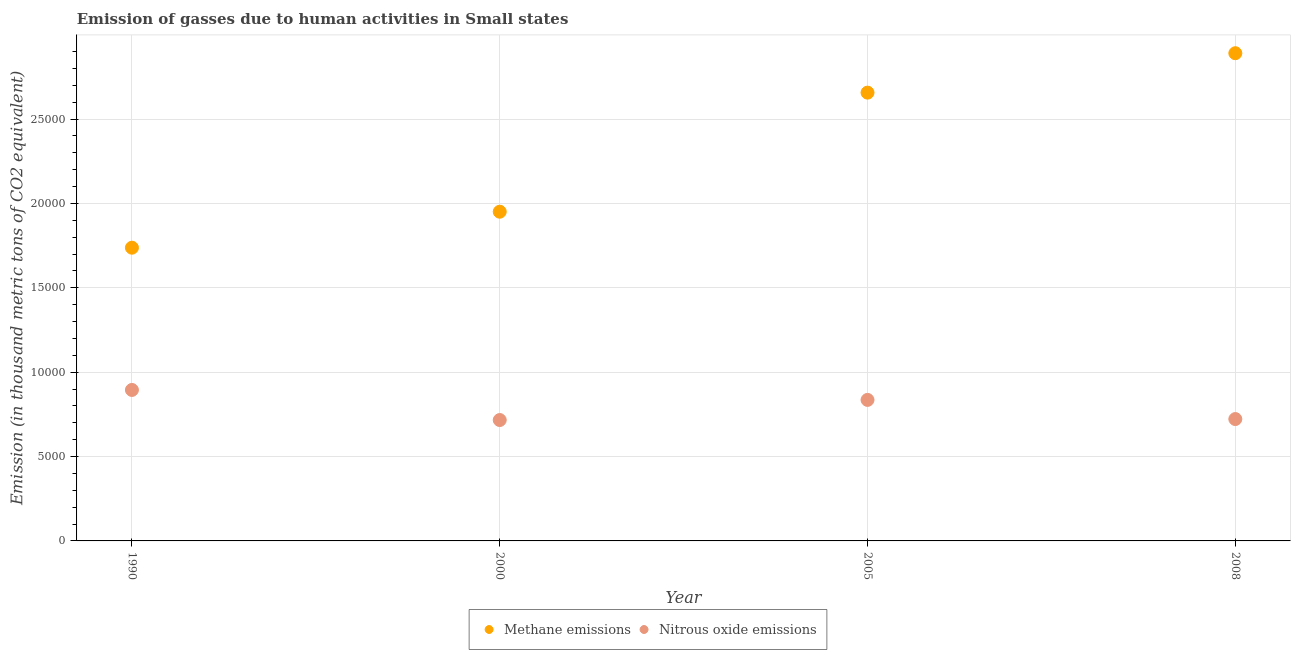How many different coloured dotlines are there?
Ensure brevity in your answer.  2. Is the number of dotlines equal to the number of legend labels?
Make the answer very short. Yes. What is the amount of methane emissions in 2008?
Keep it short and to the point. 2.89e+04. Across all years, what is the maximum amount of nitrous oxide emissions?
Offer a very short reply. 8947.8. Across all years, what is the minimum amount of methane emissions?
Ensure brevity in your answer.  1.74e+04. In which year was the amount of methane emissions maximum?
Offer a terse response. 2008. What is the total amount of methane emissions in the graph?
Offer a terse response. 9.24e+04. What is the difference between the amount of methane emissions in 1990 and that in 2000?
Your answer should be very brief. -2132.9. What is the difference between the amount of methane emissions in 2000 and the amount of nitrous oxide emissions in 2008?
Keep it short and to the point. 1.23e+04. What is the average amount of nitrous oxide emissions per year?
Offer a terse response. 7923.32. In the year 1990, what is the difference between the amount of methane emissions and amount of nitrous oxide emissions?
Ensure brevity in your answer.  8430.9. In how many years, is the amount of methane emissions greater than 9000 thousand metric tons?
Provide a short and direct response. 4. What is the ratio of the amount of nitrous oxide emissions in 2000 to that in 2005?
Offer a terse response. 0.86. What is the difference between the highest and the second highest amount of nitrous oxide emissions?
Give a very brief answer. 589.7. What is the difference between the highest and the lowest amount of methane emissions?
Make the answer very short. 1.15e+04. In how many years, is the amount of methane emissions greater than the average amount of methane emissions taken over all years?
Your response must be concise. 2. Is the sum of the amount of methane emissions in 1990 and 2005 greater than the maximum amount of nitrous oxide emissions across all years?
Provide a short and direct response. Yes. Does the amount of nitrous oxide emissions monotonically increase over the years?
Give a very brief answer. No. Is the amount of nitrous oxide emissions strictly greater than the amount of methane emissions over the years?
Ensure brevity in your answer.  No. How many dotlines are there?
Offer a very short reply. 2. What is the difference between two consecutive major ticks on the Y-axis?
Your answer should be compact. 5000. Are the values on the major ticks of Y-axis written in scientific E-notation?
Keep it short and to the point. No. Does the graph contain any zero values?
Offer a terse response. No. Where does the legend appear in the graph?
Provide a succinct answer. Bottom center. What is the title of the graph?
Give a very brief answer. Emission of gasses due to human activities in Small states. Does "National Tourists" appear as one of the legend labels in the graph?
Your response must be concise. No. What is the label or title of the X-axis?
Your answer should be compact. Year. What is the label or title of the Y-axis?
Provide a short and direct response. Emission (in thousand metric tons of CO2 equivalent). What is the Emission (in thousand metric tons of CO2 equivalent) in Methane emissions in 1990?
Your answer should be very brief. 1.74e+04. What is the Emission (in thousand metric tons of CO2 equivalent) of Nitrous oxide emissions in 1990?
Offer a very short reply. 8947.8. What is the Emission (in thousand metric tons of CO2 equivalent) of Methane emissions in 2000?
Ensure brevity in your answer.  1.95e+04. What is the Emission (in thousand metric tons of CO2 equivalent) in Nitrous oxide emissions in 2000?
Your answer should be compact. 7164.7. What is the Emission (in thousand metric tons of CO2 equivalent) of Methane emissions in 2005?
Offer a very short reply. 2.66e+04. What is the Emission (in thousand metric tons of CO2 equivalent) of Nitrous oxide emissions in 2005?
Offer a very short reply. 8358.1. What is the Emission (in thousand metric tons of CO2 equivalent) of Methane emissions in 2008?
Your answer should be very brief. 2.89e+04. What is the Emission (in thousand metric tons of CO2 equivalent) of Nitrous oxide emissions in 2008?
Give a very brief answer. 7222.7. Across all years, what is the maximum Emission (in thousand metric tons of CO2 equivalent) of Methane emissions?
Provide a succinct answer. 2.89e+04. Across all years, what is the maximum Emission (in thousand metric tons of CO2 equivalent) of Nitrous oxide emissions?
Provide a succinct answer. 8947.8. Across all years, what is the minimum Emission (in thousand metric tons of CO2 equivalent) in Methane emissions?
Offer a terse response. 1.74e+04. Across all years, what is the minimum Emission (in thousand metric tons of CO2 equivalent) of Nitrous oxide emissions?
Make the answer very short. 7164.7. What is the total Emission (in thousand metric tons of CO2 equivalent) of Methane emissions in the graph?
Offer a very short reply. 9.24e+04. What is the total Emission (in thousand metric tons of CO2 equivalent) of Nitrous oxide emissions in the graph?
Provide a succinct answer. 3.17e+04. What is the difference between the Emission (in thousand metric tons of CO2 equivalent) in Methane emissions in 1990 and that in 2000?
Your answer should be very brief. -2132.9. What is the difference between the Emission (in thousand metric tons of CO2 equivalent) of Nitrous oxide emissions in 1990 and that in 2000?
Your response must be concise. 1783.1. What is the difference between the Emission (in thousand metric tons of CO2 equivalent) of Methane emissions in 1990 and that in 2005?
Provide a short and direct response. -9189.8. What is the difference between the Emission (in thousand metric tons of CO2 equivalent) of Nitrous oxide emissions in 1990 and that in 2005?
Provide a short and direct response. 589.7. What is the difference between the Emission (in thousand metric tons of CO2 equivalent) in Methane emissions in 1990 and that in 2008?
Ensure brevity in your answer.  -1.15e+04. What is the difference between the Emission (in thousand metric tons of CO2 equivalent) of Nitrous oxide emissions in 1990 and that in 2008?
Keep it short and to the point. 1725.1. What is the difference between the Emission (in thousand metric tons of CO2 equivalent) in Methane emissions in 2000 and that in 2005?
Make the answer very short. -7056.9. What is the difference between the Emission (in thousand metric tons of CO2 equivalent) in Nitrous oxide emissions in 2000 and that in 2005?
Give a very brief answer. -1193.4. What is the difference between the Emission (in thousand metric tons of CO2 equivalent) in Methane emissions in 2000 and that in 2008?
Your answer should be very brief. -9393.1. What is the difference between the Emission (in thousand metric tons of CO2 equivalent) in Nitrous oxide emissions in 2000 and that in 2008?
Your response must be concise. -58. What is the difference between the Emission (in thousand metric tons of CO2 equivalent) of Methane emissions in 2005 and that in 2008?
Make the answer very short. -2336.2. What is the difference between the Emission (in thousand metric tons of CO2 equivalent) in Nitrous oxide emissions in 2005 and that in 2008?
Your response must be concise. 1135.4. What is the difference between the Emission (in thousand metric tons of CO2 equivalent) of Methane emissions in 1990 and the Emission (in thousand metric tons of CO2 equivalent) of Nitrous oxide emissions in 2000?
Make the answer very short. 1.02e+04. What is the difference between the Emission (in thousand metric tons of CO2 equivalent) in Methane emissions in 1990 and the Emission (in thousand metric tons of CO2 equivalent) in Nitrous oxide emissions in 2005?
Provide a short and direct response. 9020.6. What is the difference between the Emission (in thousand metric tons of CO2 equivalent) of Methane emissions in 1990 and the Emission (in thousand metric tons of CO2 equivalent) of Nitrous oxide emissions in 2008?
Your answer should be very brief. 1.02e+04. What is the difference between the Emission (in thousand metric tons of CO2 equivalent) in Methane emissions in 2000 and the Emission (in thousand metric tons of CO2 equivalent) in Nitrous oxide emissions in 2005?
Offer a very short reply. 1.12e+04. What is the difference between the Emission (in thousand metric tons of CO2 equivalent) in Methane emissions in 2000 and the Emission (in thousand metric tons of CO2 equivalent) in Nitrous oxide emissions in 2008?
Make the answer very short. 1.23e+04. What is the difference between the Emission (in thousand metric tons of CO2 equivalent) in Methane emissions in 2005 and the Emission (in thousand metric tons of CO2 equivalent) in Nitrous oxide emissions in 2008?
Give a very brief answer. 1.93e+04. What is the average Emission (in thousand metric tons of CO2 equivalent) in Methane emissions per year?
Your answer should be very brief. 2.31e+04. What is the average Emission (in thousand metric tons of CO2 equivalent) of Nitrous oxide emissions per year?
Your response must be concise. 7923.32. In the year 1990, what is the difference between the Emission (in thousand metric tons of CO2 equivalent) in Methane emissions and Emission (in thousand metric tons of CO2 equivalent) in Nitrous oxide emissions?
Give a very brief answer. 8430.9. In the year 2000, what is the difference between the Emission (in thousand metric tons of CO2 equivalent) in Methane emissions and Emission (in thousand metric tons of CO2 equivalent) in Nitrous oxide emissions?
Ensure brevity in your answer.  1.23e+04. In the year 2005, what is the difference between the Emission (in thousand metric tons of CO2 equivalent) of Methane emissions and Emission (in thousand metric tons of CO2 equivalent) of Nitrous oxide emissions?
Keep it short and to the point. 1.82e+04. In the year 2008, what is the difference between the Emission (in thousand metric tons of CO2 equivalent) in Methane emissions and Emission (in thousand metric tons of CO2 equivalent) in Nitrous oxide emissions?
Your response must be concise. 2.17e+04. What is the ratio of the Emission (in thousand metric tons of CO2 equivalent) of Methane emissions in 1990 to that in 2000?
Give a very brief answer. 0.89. What is the ratio of the Emission (in thousand metric tons of CO2 equivalent) in Nitrous oxide emissions in 1990 to that in 2000?
Your answer should be very brief. 1.25. What is the ratio of the Emission (in thousand metric tons of CO2 equivalent) in Methane emissions in 1990 to that in 2005?
Your response must be concise. 0.65. What is the ratio of the Emission (in thousand metric tons of CO2 equivalent) in Nitrous oxide emissions in 1990 to that in 2005?
Provide a succinct answer. 1.07. What is the ratio of the Emission (in thousand metric tons of CO2 equivalent) in Methane emissions in 1990 to that in 2008?
Provide a short and direct response. 0.6. What is the ratio of the Emission (in thousand metric tons of CO2 equivalent) in Nitrous oxide emissions in 1990 to that in 2008?
Your answer should be compact. 1.24. What is the ratio of the Emission (in thousand metric tons of CO2 equivalent) in Methane emissions in 2000 to that in 2005?
Offer a very short reply. 0.73. What is the ratio of the Emission (in thousand metric tons of CO2 equivalent) of Nitrous oxide emissions in 2000 to that in 2005?
Your response must be concise. 0.86. What is the ratio of the Emission (in thousand metric tons of CO2 equivalent) of Methane emissions in 2000 to that in 2008?
Your answer should be compact. 0.68. What is the ratio of the Emission (in thousand metric tons of CO2 equivalent) in Nitrous oxide emissions in 2000 to that in 2008?
Offer a very short reply. 0.99. What is the ratio of the Emission (in thousand metric tons of CO2 equivalent) in Methane emissions in 2005 to that in 2008?
Provide a succinct answer. 0.92. What is the ratio of the Emission (in thousand metric tons of CO2 equivalent) in Nitrous oxide emissions in 2005 to that in 2008?
Make the answer very short. 1.16. What is the difference between the highest and the second highest Emission (in thousand metric tons of CO2 equivalent) in Methane emissions?
Your answer should be very brief. 2336.2. What is the difference between the highest and the second highest Emission (in thousand metric tons of CO2 equivalent) in Nitrous oxide emissions?
Provide a succinct answer. 589.7. What is the difference between the highest and the lowest Emission (in thousand metric tons of CO2 equivalent) of Methane emissions?
Offer a terse response. 1.15e+04. What is the difference between the highest and the lowest Emission (in thousand metric tons of CO2 equivalent) of Nitrous oxide emissions?
Offer a very short reply. 1783.1. 